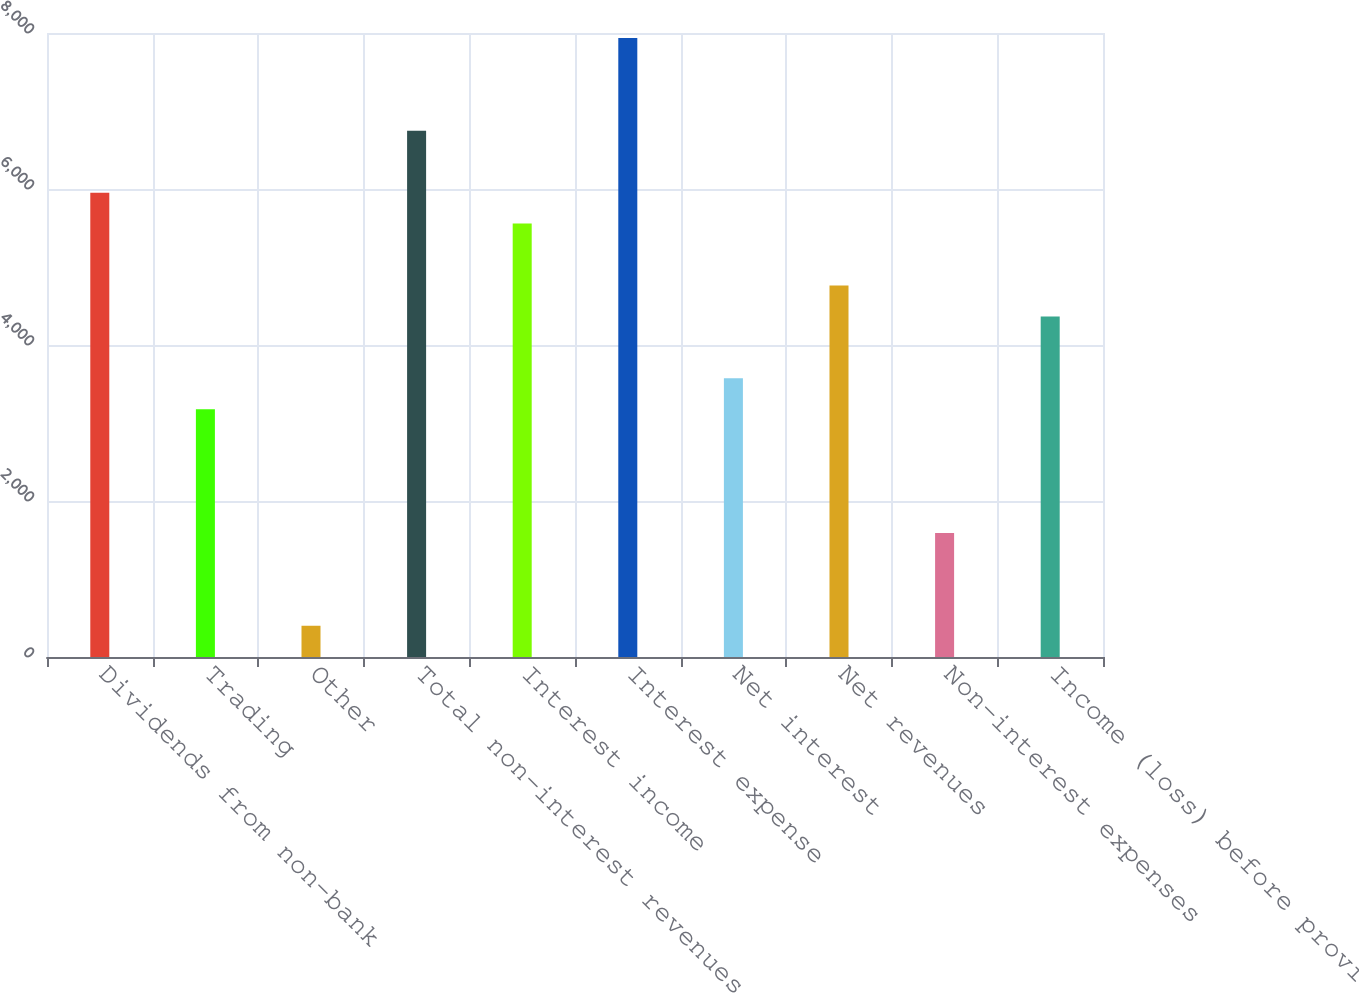Convert chart to OTSL. <chart><loc_0><loc_0><loc_500><loc_500><bar_chart><fcel>Dividends from non-bank<fcel>Trading<fcel>Other<fcel>Total non-interest revenues<fcel>Interest income<fcel>Interest expense<fcel>Net interest<fcel>Net revenues<fcel>Non-interest expenses<fcel>Income (loss) before provision<nl><fcel>5953<fcel>3176.8<fcel>400.6<fcel>6746.2<fcel>5556.4<fcel>7936<fcel>3573.4<fcel>4763.2<fcel>1590.4<fcel>4366.6<nl></chart> 